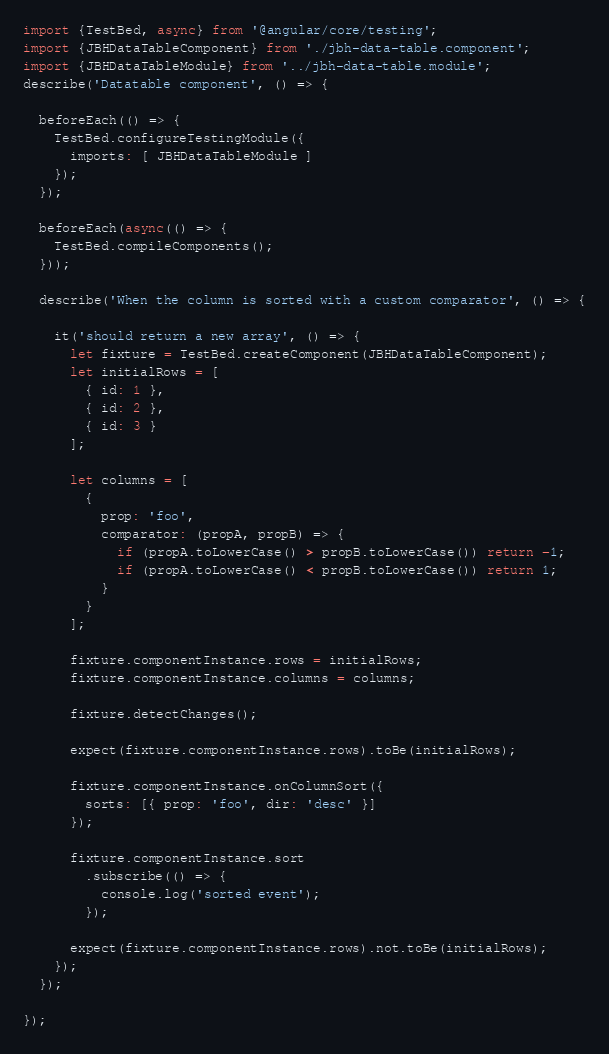<code> <loc_0><loc_0><loc_500><loc_500><_TypeScript_>import {TestBed, async} from '@angular/core/testing';
import {JBHDataTableComponent} from './jbh-data-table.component';
import {JBHDataTableModule} from '../jbh-data-table.module';
describe('Datatable component', () => {

  beforeEach(() => {
    TestBed.configureTestingModule({
      imports: [ JBHDataTableModule ]
    });
  });

  beforeEach(async(() => {
    TestBed.compileComponents();
  }));

  describe('When the column is sorted with a custom comparator', () => {

    it('should return a new array', () => {
      let fixture = TestBed.createComponent(JBHDataTableComponent);
      let initialRows = [
        { id: 1 },
        { id: 2 },
        { id: 3 }
      ];

      let columns = [
        {
          prop: 'foo',
          comparator: (propA, propB) => {
            if (propA.toLowerCase() > propB.toLowerCase()) return -1;
            if (propA.toLowerCase() < propB.toLowerCase()) return 1;
          }
        }
      ];

      fixture.componentInstance.rows = initialRows;
      fixture.componentInstance.columns = columns;

      fixture.detectChanges();

      expect(fixture.componentInstance.rows).toBe(initialRows);

      fixture.componentInstance.onColumnSort({
        sorts: [{ prop: 'foo', dir: 'desc' }]
      });

      fixture.componentInstance.sort
        .subscribe(() => {
          console.log('sorted event');
        });

      expect(fixture.componentInstance.rows).not.toBe(initialRows);
    });
  });

});
</code> 